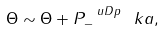Convert formula to latex. <formula><loc_0><loc_0><loc_500><loc_500>\Theta \sim \Theta + P _ { - } ^ { \ u D p } \ k a ,</formula> 